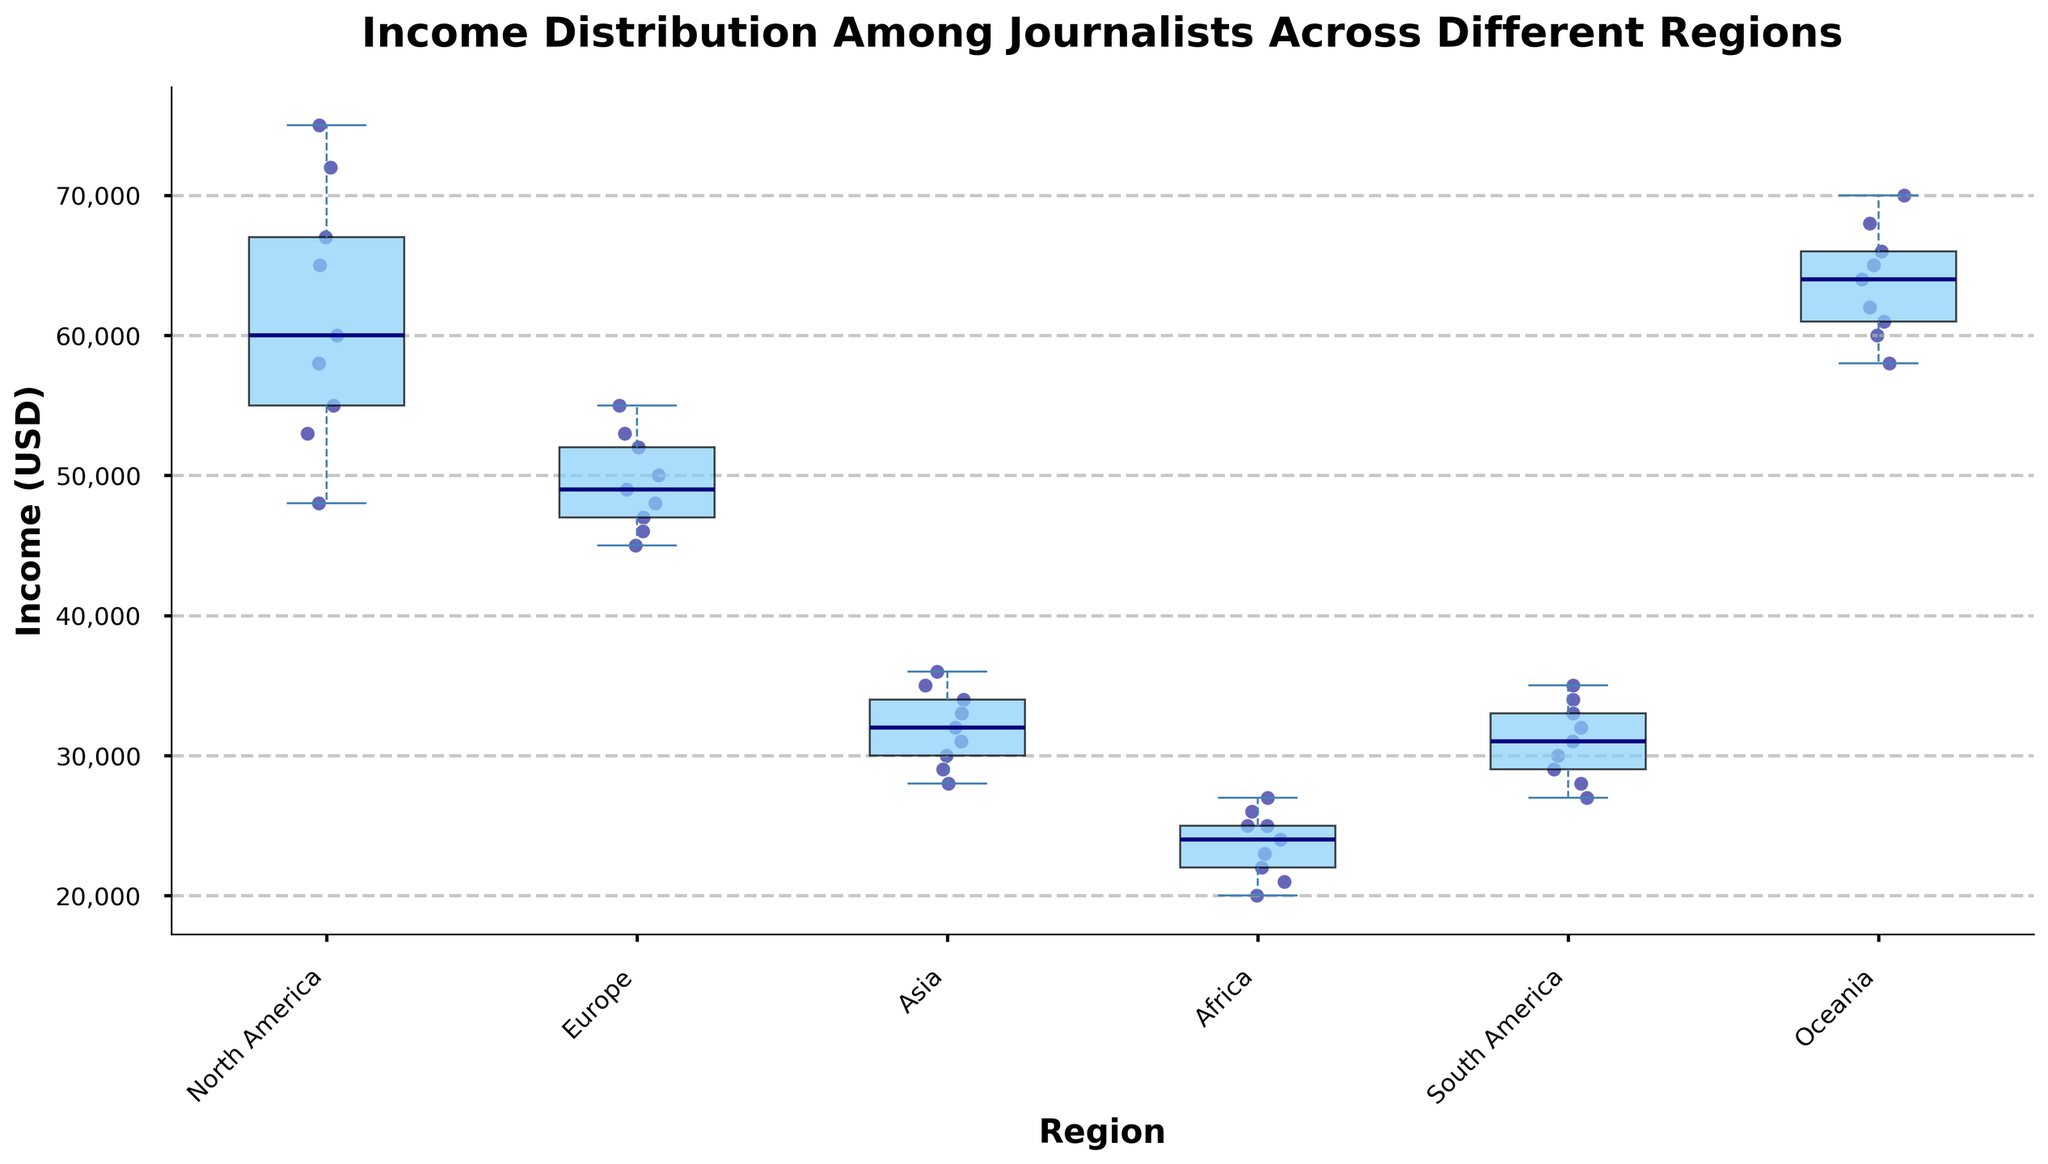What is the title of the plot? The title is written at the top of the plot and usually provides a brief description of what the plot represents. In this case, the title is "Income Distribution Among Journalists Across Different Regions".
Answer: Income Distribution Among Journalists Across Different Regions What is the median income of journalists in Europe? The median income is represented by the central line inside the box of the box plot for each region. For Europe, find the median line within the Europe box plot.
Answer: 50,000 USD Which region has the highest median income? By comparing the central lines inside the box plots of all regions, the region with the highest median line will have the highest median income.
Answer: North America Which region has the lowest range of incomes? The range of incomes in a box plot is indicated by the length from the bottom whisker to the top whisker. The region with the shortest box and whiskers has the lowest income range.
Answer: Europe Are there any regions with similar median incomes? To find if any regions have similar median incomes, compare the central lines in each box plot. Oceania and North America have similar central lines, indicating similar median incomes.
Answer: Yes, Oceania and North America What's the range of incomes for journalists in Africa? The range is the difference between the top whisker and the bottom whisker in the box plot for Africa.
Answer: 26,000 USD Which region has the most dispersed income (greatest variability)? The region with the longest span between the whiskers and/or outliers has the greatest income variability. Find this by observing the extent of the whiskers and scatter points.
Answer: North America How does the income distribution in South America compare with that in Asia? Compare the boxes and whiskers of South America and Asia in terms of their positions and spread. Both have similar lower income ranges, but South America has slightly higher values and a wider spread.
Answer: South America has a slightly higher median and wider spread than Asia Which region appears to have the most outliers in terms of income? Outliers are represented by dots that lie outside the whiskers. The region with the most dots outside the boxes and whiskers has the most outliers.
Answer: Oceania What is the general trend of incomes across the regions shown in the plot? Observe the medians, spreads, and outliers for each region to see if there is an overall pattern or trend. Regions like North America and Oceania tend to have higher incomes, whereas Africa and Asia have lower incomes.
Answer: Higher in North America and Oceania, lower in Africa and Asia 